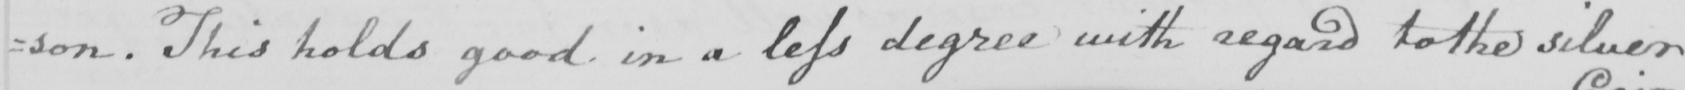Can you read and transcribe this handwriting? =son . This holds good in a less degree with regard to the silver 